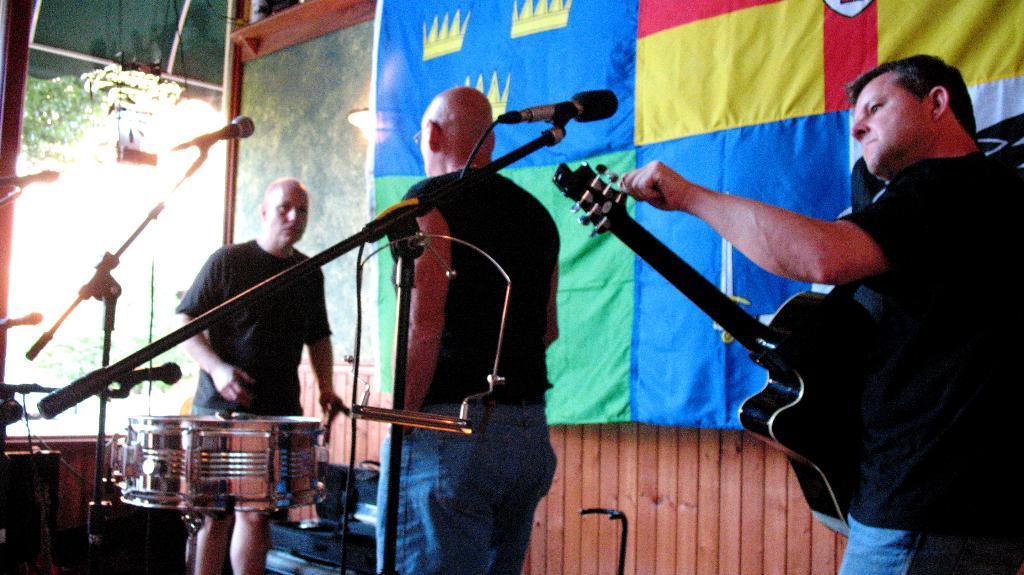Please provide a concise description of this image. This is the picture taken in a room, the man in black t shirt was holding a guitar and the other persons are standing on the floor. In front of these people there are microphones with stands. and there are some music instruments. Behind the people is a banner and a wall. 